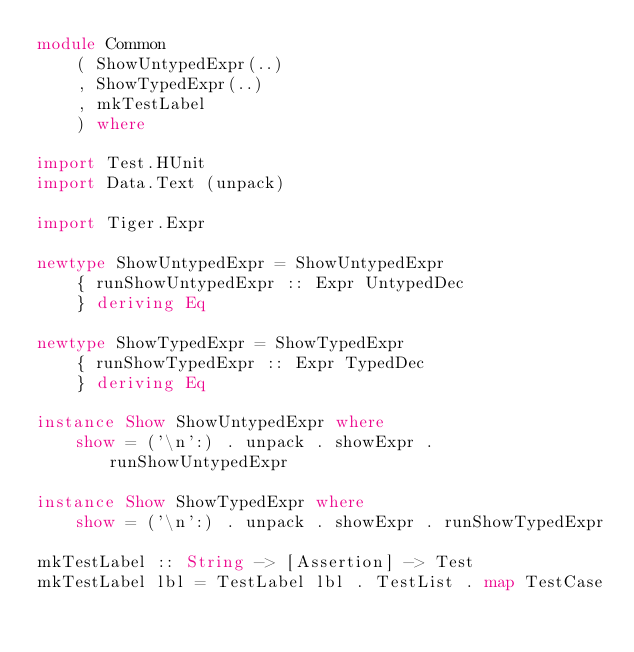<code> <loc_0><loc_0><loc_500><loc_500><_Haskell_>module Common
    ( ShowUntypedExpr(..)
    , ShowTypedExpr(..)
    , mkTestLabel
    ) where

import Test.HUnit
import Data.Text (unpack)

import Tiger.Expr

newtype ShowUntypedExpr = ShowUntypedExpr
    { runShowUntypedExpr :: Expr UntypedDec
    } deriving Eq

newtype ShowTypedExpr = ShowTypedExpr
    { runShowTypedExpr :: Expr TypedDec
    } deriving Eq

instance Show ShowUntypedExpr where
    show = ('\n':) . unpack . showExpr . runShowUntypedExpr

instance Show ShowTypedExpr where
    show = ('\n':) . unpack . showExpr . runShowTypedExpr

mkTestLabel :: String -> [Assertion] -> Test
mkTestLabel lbl = TestLabel lbl . TestList . map TestCase
</code> 